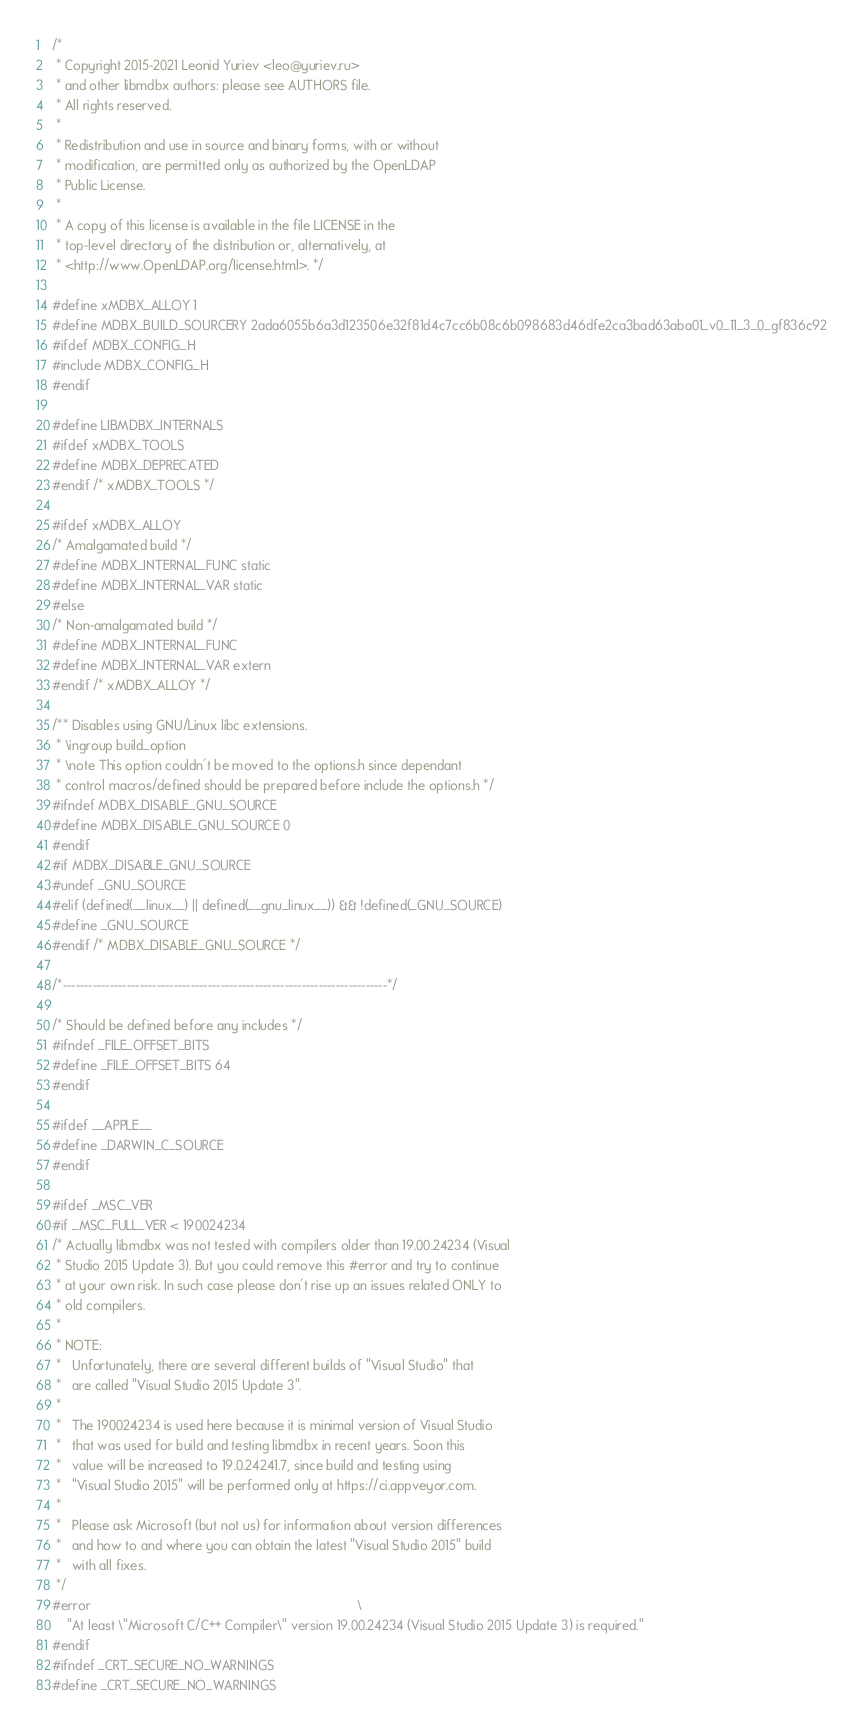Convert code to text. <code><loc_0><loc_0><loc_500><loc_500><_C++_>/*
 * Copyright 2015-2021 Leonid Yuriev <leo@yuriev.ru>
 * and other libmdbx authors: please see AUTHORS file.
 * All rights reserved.
 *
 * Redistribution and use in source and binary forms, with or without
 * modification, are permitted only as authorized by the OpenLDAP
 * Public License.
 *
 * A copy of this license is available in the file LICENSE in the
 * top-level directory of the distribution or, alternatively, at
 * <http://www.OpenLDAP.org/license.html>. */

#define xMDBX_ALLOY 1
#define MDBX_BUILD_SOURCERY 2ada6055b6a3d123506e32f81d4c7cc6b08c6b098683d46dfe2ca3bad63aba01_v0_11_3_0_gf836c92
#ifdef MDBX_CONFIG_H
#include MDBX_CONFIG_H
#endif

#define LIBMDBX_INTERNALS
#ifdef xMDBX_TOOLS
#define MDBX_DEPRECATED
#endif /* xMDBX_TOOLS */

#ifdef xMDBX_ALLOY
/* Amalgamated build */
#define MDBX_INTERNAL_FUNC static
#define MDBX_INTERNAL_VAR static
#else
/* Non-amalgamated build */
#define MDBX_INTERNAL_FUNC
#define MDBX_INTERNAL_VAR extern
#endif /* xMDBX_ALLOY */

/** Disables using GNU/Linux libc extensions.
 * \ingroup build_option
 * \note This option couldn't be moved to the options.h since dependant
 * control macros/defined should be prepared before include the options.h */
#ifndef MDBX_DISABLE_GNU_SOURCE
#define MDBX_DISABLE_GNU_SOURCE 0
#endif
#if MDBX_DISABLE_GNU_SOURCE
#undef _GNU_SOURCE
#elif (defined(__linux__) || defined(__gnu_linux__)) && !defined(_GNU_SOURCE)
#define _GNU_SOURCE
#endif /* MDBX_DISABLE_GNU_SOURCE */

/*----------------------------------------------------------------------------*/

/* Should be defined before any includes */
#ifndef _FILE_OFFSET_BITS
#define _FILE_OFFSET_BITS 64
#endif

#ifdef __APPLE__
#define _DARWIN_C_SOURCE
#endif

#ifdef _MSC_VER
#if _MSC_FULL_VER < 190024234
/* Actually libmdbx was not tested with compilers older than 19.00.24234 (Visual
 * Studio 2015 Update 3). But you could remove this #error and try to continue
 * at your own risk. In such case please don't rise up an issues related ONLY to
 * old compilers.
 *
 * NOTE:
 *   Unfortunately, there are several different builds of "Visual Studio" that
 *   are called "Visual Studio 2015 Update 3".
 *
 *   The 190024234 is used here because it is minimal version of Visual Studio
 *   that was used for build and testing libmdbx in recent years. Soon this
 *   value will be increased to 19.0.24241.7, since build and testing using
 *   "Visual Studio 2015" will be performed only at https://ci.appveyor.com.
 *
 *   Please ask Microsoft (but not us) for information about version differences
 *   and how to and where you can obtain the latest "Visual Studio 2015" build
 *   with all fixes.
 */
#error                                                                         \
    "At least \"Microsoft C/C++ Compiler\" version 19.00.24234 (Visual Studio 2015 Update 3) is required."
#endif
#ifndef _CRT_SECURE_NO_WARNINGS
#define _CRT_SECURE_NO_WARNINGS</code> 